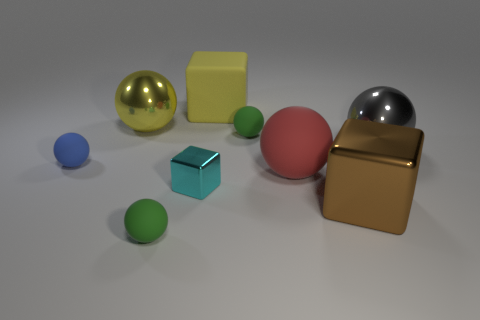Are the objects arranged in a particular pattern or structure? The objects seem to be arranged deliberately, although not in a strict geometric pattern. They are spaced out across the scene, creating a balanced composition that draws the viewer's eye across the image. The varying shapes and sizes of the objects form a pleasing visual rhythm without adhering to a precise structure. 